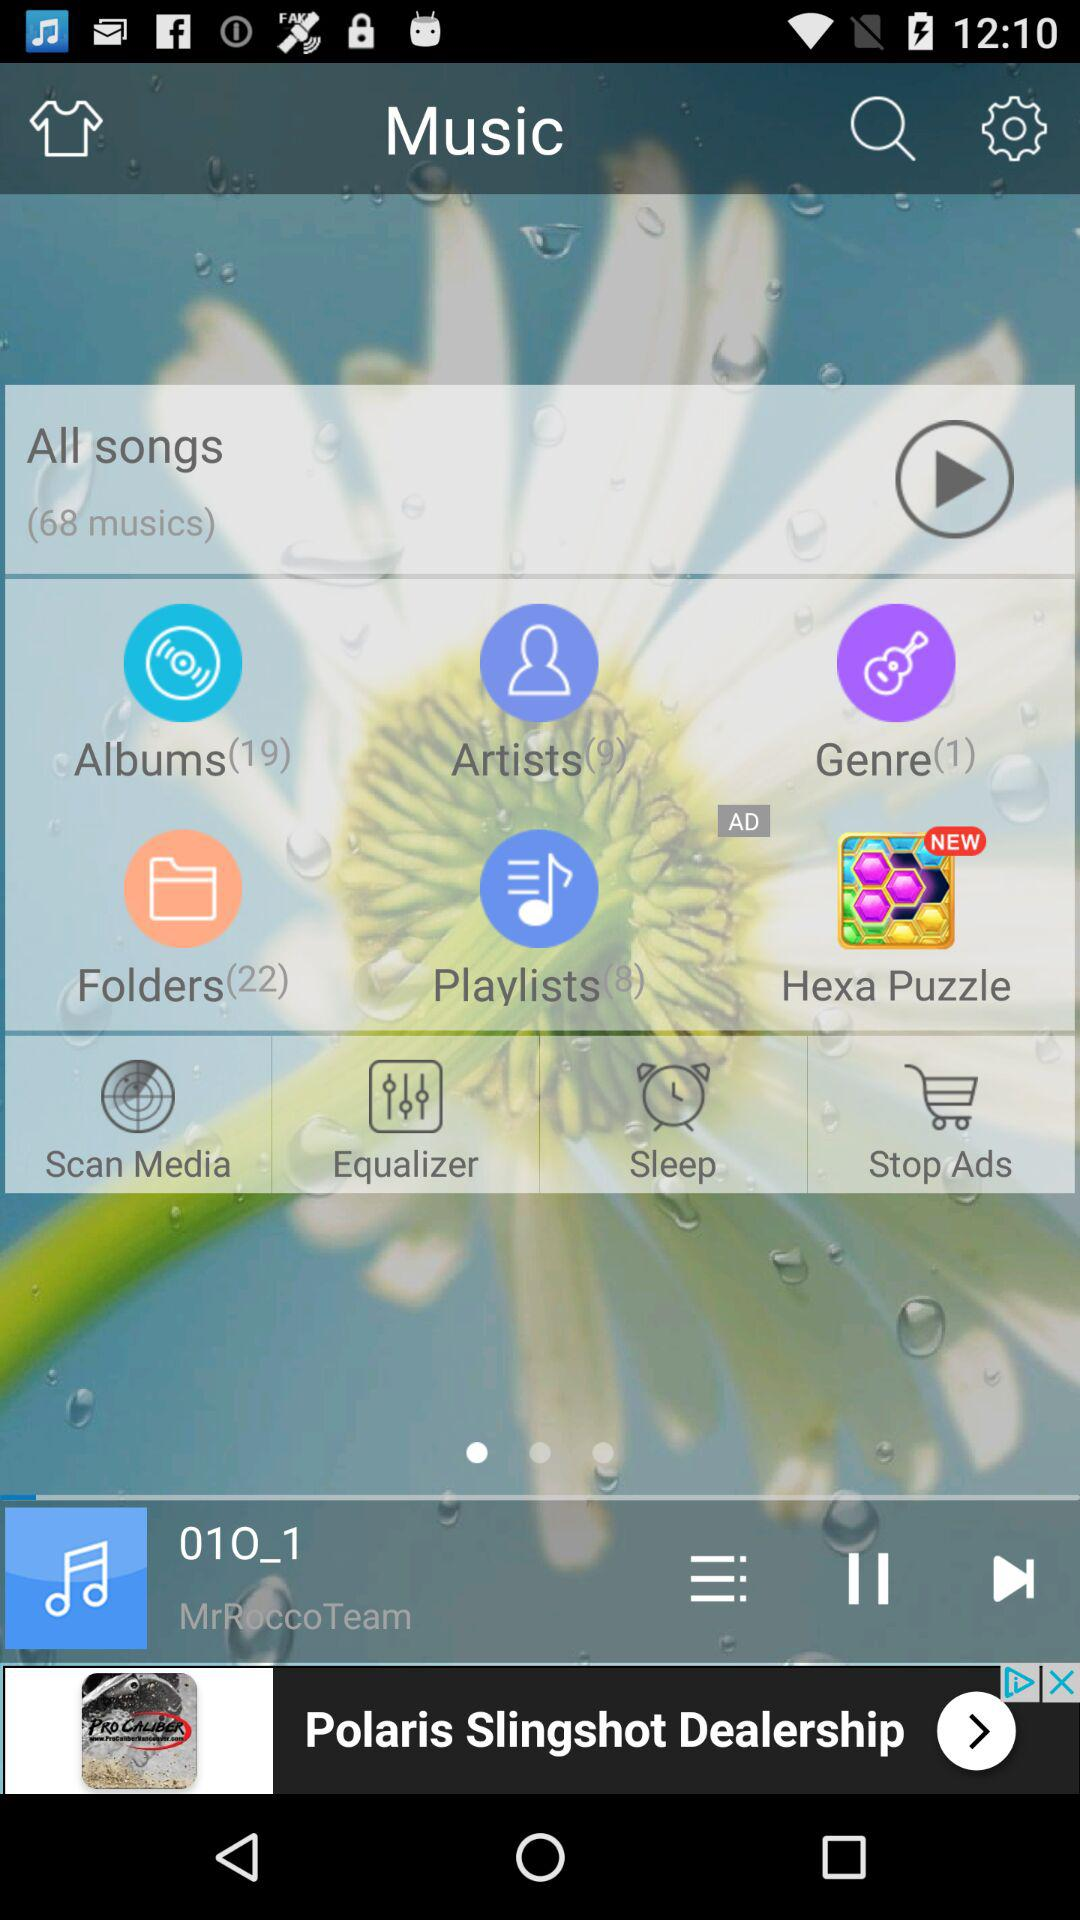Which song is currently playing? The currently playing song is "01O_1". 